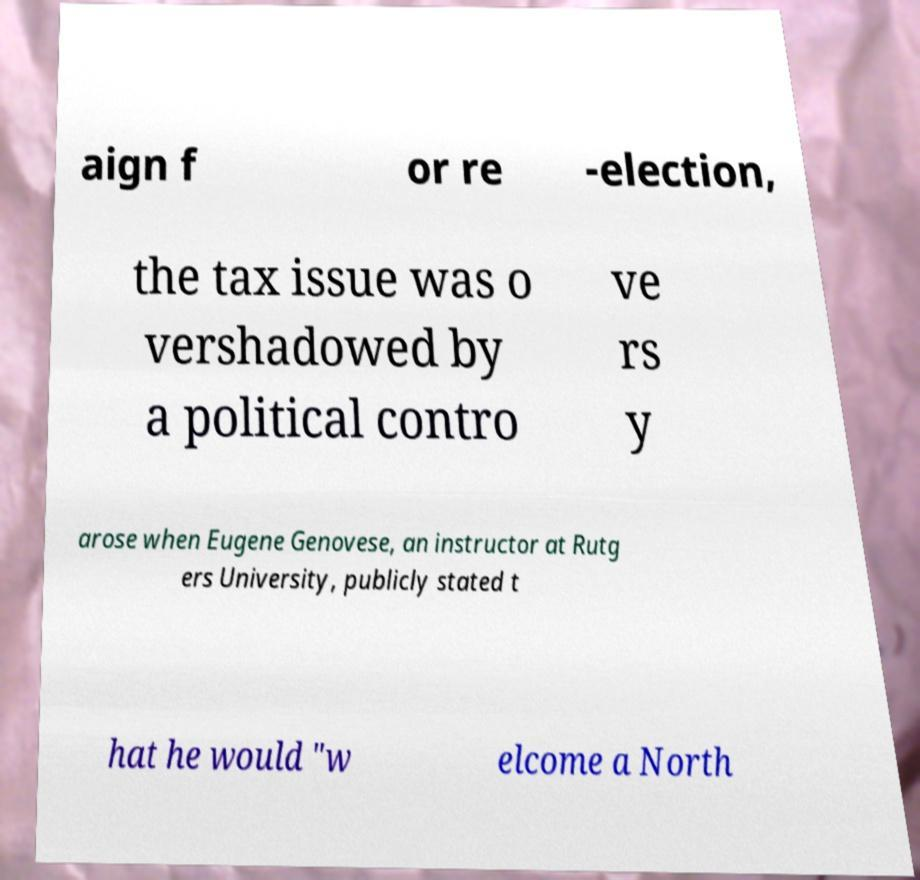There's text embedded in this image that I need extracted. Can you transcribe it verbatim? aign f or re -election, the tax issue was o vershadowed by a political contro ve rs y arose when Eugene Genovese, an instructor at Rutg ers University, publicly stated t hat he would "w elcome a North 